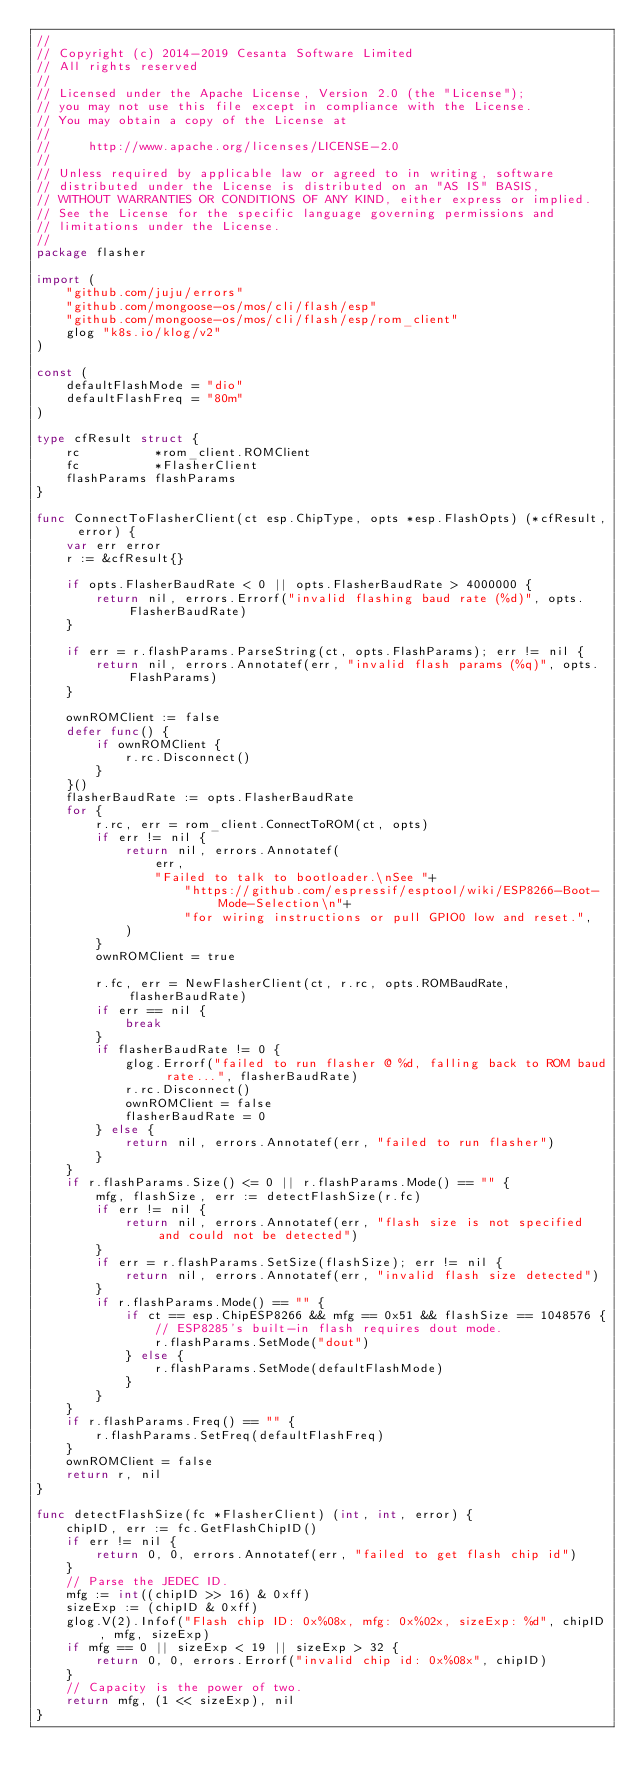<code> <loc_0><loc_0><loc_500><loc_500><_Go_>//
// Copyright (c) 2014-2019 Cesanta Software Limited
// All rights reserved
//
// Licensed under the Apache License, Version 2.0 (the "License");
// you may not use this file except in compliance with the License.
// You may obtain a copy of the License at
//
//     http://www.apache.org/licenses/LICENSE-2.0
//
// Unless required by applicable law or agreed to in writing, software
// distributed under the License is distributed on an "AS IS" BASIS,
// WITHOUT WARRANTIES OR CONDITIONS OF ANY KIND, either express or implied.
// See the License for the specific language governing permissions and
// limitations under the License.
//
package flasher

import (
	"github.com/juju/errors"
	"github.com/mongoose-os/mos/cli/flash/esp"
	"github.com/mongoose-os/mos/cli/flash/esp/rom_client"
	glog "k8s.io/klog/v2"
)

const (
	defaultFlashMode = "dio"
	defaultFlashFreq = "80m"
)

type cfResult struct {
	rc          *rom_client.ROMClient
	fc          *FlasherClient
	flashParams flashParams
}

func ConnectToFlasherClient(ct esp.ChipType, opts *esp.FlashOpts) (*cfResult, error) {
	var err error
	r := &cfResult{}

	if opts.FlasherBaudRate < 0 || opts.FlasherBaudRate > 4000000 {
		return nil, errors.Errorf("invalid flashing baud rate (%d)", opts.FlasherBaudRate)
	}

	if err = r.flashParams.ParseString(ct, opts.FlashParams); err != nil {
		return nil, errors.Annotatef(err, "invalid flash params (%q)", opts.FlashParams)
	}

	ownROMClient := false
	defer func() {
		if ownROMClient {
			r.rc.Disconnect()
		}
	}()
	flasherBaudRate := opts.FlasherBaudRate
	for {
		r.rc, err = rom_client.ConnectToROM(ct, opts)
		if err != nil {
			return nil, errors.Annotatef(
				err,
				"Failed to talk to bootloader.\nSee "+
					"https://github.com/espressif/esptool/wiki/ESP8266-Boot-Mode-Selection\n"+
					"for wiring instructions or pull GPIO0 low and reset.",
			)
		}
		ownROMClient = true

		r.fc, err = NewFlasherClient(ct, r.rc, opts.ROMBaudRate, flasherBaudRate)
		if err == nil {
			break
		}
		if flasherBaudRate != 0 {
			glog.Errorf("failed to run flasher @ %d, falling back to ROM baud rate...", flasherBaudRate)
			r.rc.Disconnect()
			ownROMClient = false
			flasherBaudRate = 0
		} else {
			return nil, errors.Annotatef(err, "failed to run flasher")
		}
	}
	if r.flashParams.Size() <= 0 || r.flashParams.Mode() == "" {
		mfg, flashSize, err := detectFlashSize(r.fc)
		if err != nil {
			return nil, errors.Annotatef(err, "flash size is not specified and could not be detected")
		}
		if err = r.flashParams.SetSize(flashSize); err != nil {
			return nil, errors.Annotatef(err, "invalid flash size detected")
		}
		if r.flashParams.Mode() == "" {
			if ct == esp.ChipESP8266 && mfg == 0x51 && flashSize == 1048576 {
				// ESP8285's built-in flash requires dout mode.
				r.flashParams.SetMode("dout")
			} else {
				r.flashParams.SetMode(defaultFlashMode)
			}
		}
	}
	if r.flashParams.Freq() == "" {
		r.flashParams.SetFreq(defaultFlashFreq)
	}
	ownROMClient = false
	return r, nil
}

func detectFlashSize(fc *FlasherClient) (int, int, error) {
	chipID, err := fc.GetFlashChipID()
	if err != nil {
		return 0, 0, errors.Annotatef(err, "failed to get flash chip id")
	}
	// Parse the JEDEC ID.
	mfg := int((chipID >> 16) & 0xff)
	sizeExp := (chipID & 0xff)
	glog.V(2).Infof("Flash chip ID: 0x%08x, mfg: 0x%02x, sizeExp: %d", chipID, mfg, sizeExp)
	if mfg == 0 || sizeExp < 19 || sizeExp > 32 {
		return 0, 0, errors.Errorf("invalid chip id: 0x%08x", chipID)
	}
	// Capacity is the power of two.
	return mfg, (1 << sizeExp), nil
}
</code> 